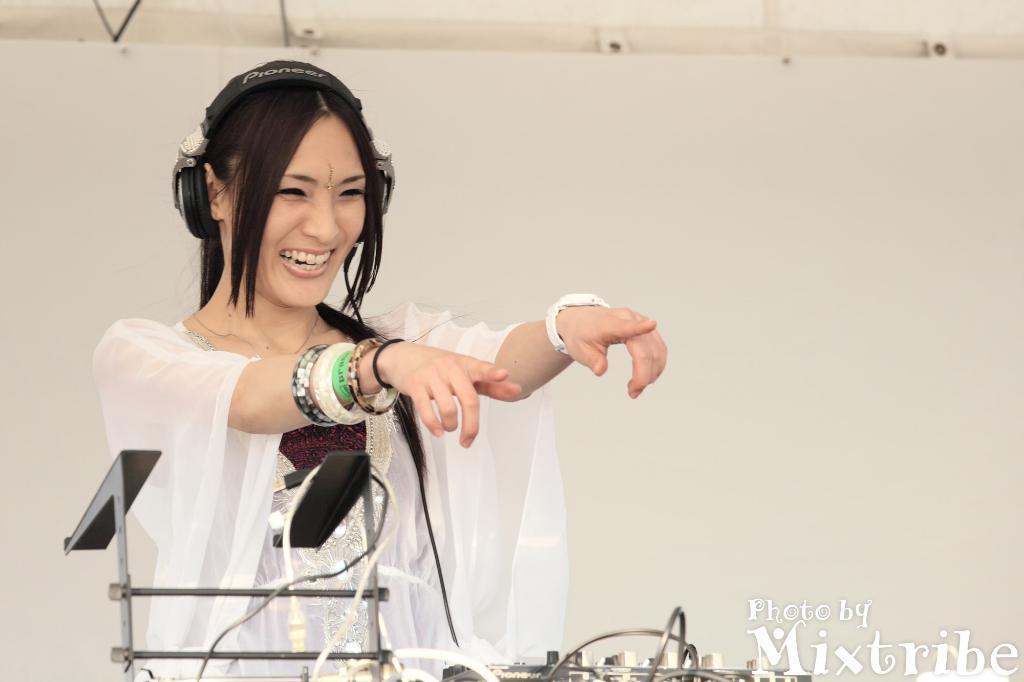Can you describe this image briefly? In this image I can see a woman wearing white color dress. In front I can see a ash color object. Background is in white color. 